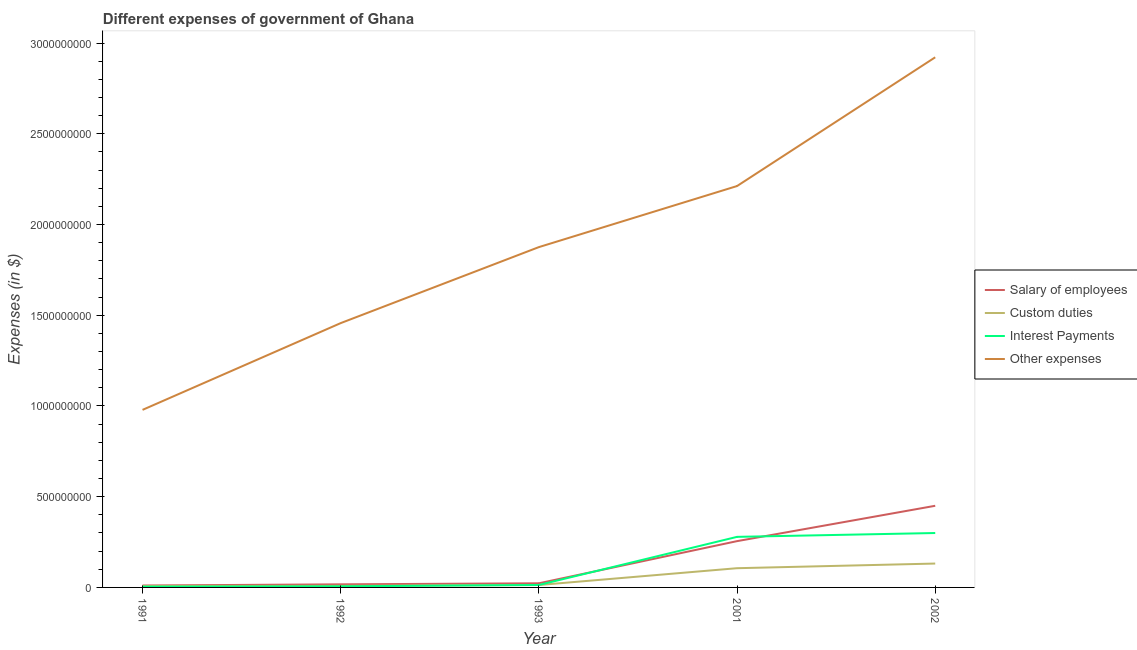How many different coloured lines are there?
Keep it short and to the point. 4. Does the line corresponding to amount spent on salary of employees intersect with the line corresponding to amount spent on other expenses?
Provide a succinct answer. No. Is the number of lines equal to the number of legend labels?
Your answer should be compact. Yes. What is the amount spent on custom duties in 1992?
Your answer should be compact. 8.66e+06. Across all years, what is the maximum amount spent on other expenses?
Ensure brevity in your answer.  2.92e+09. Across all years, what is the minimum amount spent on interest payments?
Offer a very short reply. 4.28e+06. In which year was the amount spent on salary of employees minimum?
Offer a terse response. 1991. What is the total amount spent on salary of employees in the graph?
Offer a terse response. 7.56e+08. What is the difference between the amount spent on salary of employees in 2001 and that in 2002?
Your answer should be compact. -1.95e+08. What is the difference between the amount spent on custom duties in 1991 and the amount spent on salary of employees in 2001?
Provide a succinct answer. -2.47e+08. What is the average amount spent on salary of employees per year?
Offer a terse response. 1.51e+08. In the year 1991, what is the difference between the amount spent on custom duties and amount spent on other expenses?
Your answer should be compact. -9.71e+08. What is the ratio of the amount spent on other expenses in 1991 to that in 1992?
Your answer should be very brief. 0.67. Is the amount spent on salary of employees in 1991 less than that in 2001?
Offer a very short reply. Yes. Is the difference between the amount spent on custom duties in 1991 and 2002 greater than the difference between the amount spent on salary of employees in 1991 and 2002?
Keep it short and to the point. Yes. What is the difference between the highest and the second highest amount spent on other expenses?
Provide a short and direct response. 7.10e+08. What is the difference between the highest and the lowest amount spent on salary of employees?
Make the answer very short. 4.39e+08. In how many years, is the amount spent on custom duties greater than the average amount spent on custom duties taken over all years?
Provide a short and direct response. 2. Is the sum of the amount spent on other expenses in 1993 and 2002 greater than the maximum amount spent on salary of employees across all years?
Your answer should be very brief. Yes. Is it the case that in every year, the sum of the amount spent on custom duties and amount spent on salary of employees is greater than the sum of amount spent on other expenses and amount spent on interest payments?
Offer a very short reply. No. Does the amount spent on salary of employees monotonically increase over the years?
Make the answer very short. Yes. Is the amount spent on other expenses strictly greater than the amount spent on salary of employees over the years?
Give a very brief answer. Yes. How many lines are there?
Offer a very short reply. 4. How many years are there in the graph?
Make the answer very short. 5. Does the graph contain any zero values?
Ensure brevity in your answer.  No. How many legend labels are there?
Your answer should be compact. 4. What is the title of the graph?
Your response must be concise. Different expenses of government of Ghana. Does "Forest" appear as one of the legend labels in the graph?
Your response must be concise. No. What is the label or title of the X-axis?
Provide a short and direct response. Year. What is the label or title of the Y-axis?
Your answer should be compact. Expenses (in $). What is the Expenses (in $) in Salary of employees in 1991?
Give a very brief answer. 1.06e+07. What is the Expenses (in $) in Custom duties in 1991?
Give a very brief answer. 7.93e+06. What is the Expenses (in $) of Interest Payments in 1991?
Your answer should be compact. 4.28e+06. What is the Expenses (in $) of Other expenses in 1991?
Offer a very short reply. 9.79e+08. What is the Expenses (in $) of Salary of employees in 1992?
Give a very brief answer. 1.71e+07. What is the Expenses (in $) in Custom duties in 1992?
Ensure brevity in your answer.  8.66e+06. What is the Expenses (in $) of Interest Payments in 1992?
Ensure brevity in your answer.  6.10e+06. What is the Expenses (in $) in Other expenses in 1992?
Offer a terse response. 1.46e+09. What is the Expenses (in $) of Salary of employees in 1993?
Ensure brevity in your answer.  2.28e+07. What is the Expenses (in $) in Custom duties in 1993?
Give a very brief answer. 1.33e+07. What is the Expenses (in $) of Interest Payments in 1993?
Your response must be concise. 1.35e+07. What is the Expenses (in $) of Other expenses in 1993?
Provide a short and direct response. 1.88e+09. What is the Expenses (in $) in Salary of employees in 2001?
Make the answer very short. 2.55e+08. What is the Expenses (in $) of Custom duties in 2001?
Offer a very short reply. 1.06e+08. What is the Expenses (in $) in Interest Payments in 2001?
Offer a terse response. 2.79e+08. What is the Expenses (in $) in Other expenses in 2001?
Provide a short and direct response. 2.21e+09. What is the Expenses (in $) in Salary of employees in 2002?
Provide a succinct answer. 4.50e+08. What is the Expenses (in $) in Custom duties in 2002?
Your answer should be very brief. 1.32e+08. What is the Expenses (in $) in Interest Payments in 2002?
Your answer should be very brief. 3.00e+08. What is the Expenses (in $) in Other expenses in 2002?
Keep it short and to the point. 2.92e+09. Across all years, what is the maximum Expenses (in $) in Salary of employees?
Give a very brief answer. 4.50e+08. Across all years, what is the maximum Expenses (in $) in Custom duties?
Your answer should be very brief. 1.32e+08. Across all years, what is the maximum Expenses (in $) in Interest Payments?
Your response must be concise. 3.00e+08. Across all years, what is the maximum Expenses (in $) in Other expenses?
Offer a very short reply. 2.92e+09. Across all years, what is the minimum Expenses (in $) in Salary of employees?
Make the answer very short. 1.06e+07. Across all years, what is the minimum Expenses (in $) of Custom duties?
Keep it short and to the point. 7.93e+06. Across all years, what is the minimum Expenses (in $) in Interest Payments?
Keep it short and to the point. 4.28e+06. Across all years, what is the minimum Expenses (in $) in Other expenses?
Your answer should be very brief. 9.79e+08. What is the total Expenses (in $) of Salary of employees in the graph?
Keep it short and to the point. 7.56e+08. What is the total Expenses (in $) of Custom duties in the graph?
Offer a very short reply. 2.67e+08. What is the total Expenses (in $) in Interest Payments in the graph?
Your response must be concise. 6.02e+08. What is the total Expenses (in $) of Other expenses in the graph?
Make the answer very short. 9.45e+09. What is the difference between the Expenses (in $) of Salary of employees in 1991 and that in 1992?
Offer a terse response. -6.55e+06. What is the difference between the Expenses (in $) in Custom duties in 1991 and that in 1992?
Your answer should be very brief. -7.33e+05. What is the difference between the Expenses (in $) of Interest Payments in 1991 and that in 1992?
Provide a short and direct response. -1.82e+06. What is the difference between the Expenses (in $) of Other expenses in 1991 and that in 1992?
Provide a succinct answer. -4.78e+08. What is the difference between the Expenses (in $) of Salary of employees in 1991 and that in 1993?
Offer a terse response. -1.22e+07. What is the difference between the Expenses (in $) in Custom duties in 1991 and that in 1993?
Ensure brevity in your answer.  -5.34e+06. What is the difference between the Expenses (in $) of Interest Payments in 1991 and that in 1993?
Your response must be concise. -9.20e+06. What is the difference between the Expenses (in $) of Other expenses in 1991 and that in 1993?
Your response must be concise. -8.97e+08. What is the difference between the Expenses (in $) of Salary of employees in 1991 and that in 2001?
Provide a short and direct response. -2.45e+08. What is the difference between the Expenses (in $) of Custom duties in 1991 and that in 2001?
Keep it short and to the point. -9.81e+07. What is the difference between the Expenses (in $) in Interest Payments in 1991 and that in 2001?
Make the answer very short. -2.74e+08. What is the difference between the Expenses (in $) of Other expenses in 1991 and that in 2001?
Make the answer very short. -1.23e+09. What is the difference between the Expenses (in $) of Salary of employees in 1991 and that in 2002?
Ensure brevity in your answer.  -4.39e+08. What is the difference between the Expenses (in $) of Custom duties in 1991 and that in 2002?
Keep it short and to the point. -1.24e+08. What is the difference between the Expenses (in $) of Interest Payments in 1991 and that in 2002?
Ensure brevity in your answer.  -2.96e+08. What is the difference between the Expenses (in $) of Other expenses in 1991 and that in 2002?
Give a very brief answer. -1.94e+09. What is the difference between the Expenses (in $) of Salary of employees in 1992 and that in 1993?
Offer a very short reply. -5.65e+06. What is the difference between the Expenses (in $) in Custom duties in 1992 and that in 1993?
Keep it short and to the point. -4.61e+06. What is the difference between the Expenses (in $) in Interest Payments in 1992 and that in 1993?
Your answer should be compact. -7.38e+06. What is the difference between the Expenses (in $) in Other expenses in 1992 and that in 1993?
Keep it short and to the point. -4.19e+08. What is the difference between the Expenses (in $) of Salary of employees in 1992 and that in 2001?
Keep it short and to the point. -2.38e+08. What is the difference between the Expenses (in $) in Custom duties in 1992 and that in 2001?
Give a very brief answer. -9.73e+07. What is the difference between the Expenses (in $) of Interest Payments in 1992 and that in 2001?
Provide a short and direct response. -2.73e+08. What is the difference between the Expenses (in $) in Other expenses in 1992 and that in 2001?
Your answer should be very brief. -7.55e+08. What is the difference between the Expenses (in $) of Salary of employees in 1992 and that in 2002?
Offer a very short reply. -4.33e+08. What is the difference between the Expenses (in $) in Custom duties in 1992 and that in 2002?
Offer a very short reply. -1.23e+08. What is the difference between the Expenses (in $) of Interest Payments in 1992 and that in 2002?
Provide a succinct answer. -2.94e+08. What is the difference between the Expenses (in $) of Other expenses in 1992 and that in 2002?
Offer a very short reply. -1.47e+09. What is the difference between the Expenses (in $) in Salary of employees in 1993 and that in 2001?
Ensure brevity in your answer.  -2.32e+08. What is the difference between the Expenses (in $) in Custom duties in 1993 and that in 2001?
Ensure brevity in your answer.  -9.27e+07. What is the difference between the Expenses (in $) in Interest Payments in 1993 and that in 2001?
Ensure brevity in your answer.  -2.65e+08. What is the difference between the Expenses (in $) of Other expenses in 1993 and that in 2001?
Keep it short and to the point. -3.37e+08. What is the difference between the Expenses (in $) in Salary of employees in 1993 and that in 2002?
Keep it short and to the point. -4.27e+08. What is the difference between the Expenses (in $) of Custom duties in 1993 and that in 2002?
Make the answer very short. -1.18e+08. What is the difference between the Expenses (in $) of Interest Payments in 1993 and that in 2002?
Your answer should be very brief. -2.86e+08. What is the difference between the Expenses (in $) in Other expenses in 1993 and that in 2002?
Provide a succinct answer. -1.05e+09. What is the difference between the Expenses (in $) in Salary of employees in 2001 and that in 2002?
Your answer should be compact. -1.95e+08. What is the difference between the Expenses (in $) in Custom duties in 2001 and that in 2002?
Provide a short and direct response. -2.56e+07. What is the difference between the Expenses (in $) in Interest Payments in 2001 and that in 2002?
Provide a succinct answer. -2.12e+07. What is the difference between the Expenses (in $) of Other expenses in 2001 and that in 2002?
Provide a short and direct response. -7.10e+08. What is the difference between the Expenses (in $) of Salary of employees in 1991 and the Expenses (in $) of Custom duties in 1992?
Provide a short and direct response. 1.90e+06. What is the difference between the Expenses (in $) of Salary of employees in 1991 and the Expenses (in $) of Interest Payments in 1992?
Your answer should be compact. 4.46e+06. What is the difference between the Expenses (in $) of Salary of employees in 1991 and the Expenses (in $) of Other expenses in 1992?
Provide a succinct answer. -1.45e+09. What is the difference between the Expenses (in $) of Custom duties in 1991 and the Expenses (in $) of Interest Payments in 1992?
Provide a short and direct response. 1.82e+06. What is the difference between the Expenses (in $) in Custom duties in 1991 and the Expenses (in $) in Other expenses in 1992?
Offer a very short reply. -1.45e+09. What is the difference between the Expenses (in $) of Interest Payments in 1991 and the Expenses (in $) of Other expenses in 1992?
Offer a very short reply. -1.45e+09. What is the difference between the Expenses (in $) in Salary of employees in 1991 and the Expenses (in $) in Custom duties in 1993?
Your answer should be very brief. -2.71e+06. What is the difference between the Expenses (in $) in Salary of employees in 1991 and the Expenses (in $) in Interest Payments in 1993?
Provide a succinct answer. -2.92e+06. What is the difference between the Expenses (in $) of Salary of employees in 1991 and the Expenses (in $) of Other expenses in 1993?
Offer a terse response. -1.87e+09. What is the difference between the Expenses (in $) in Custom duties in 1991 and the Expenses (in $) in Interest Payments in 1993?
Ensure brevity in your answer.  -5.55e+06. What is the difference between the Expenses (in $) of Custom duties in 1991 and the Expenses (in $) of Other expenses in 1993?
Offer a very short reply. -1.87e+09. What is the difference between the Expenses (in $) of Interest Payments in 1991 and the Expenses (in $) of Other expenses in 1993?
Your answer should be compact. -1.87e+09. What is the difference between the Expenses (in $) of Salary of employees in 1991 and the Expenses (in $) of Custom duties in 2001?
Make the answer very short. -9.54e+07. What is the difference between the Expenses (in $) of Salary of employees in 1991 and the Expenses (in $) of Interest Payments in 2001?
Ensure brevity in your answer.  -2.68e+08. What is the difference between the Expenses (in $) in Salary of employees in 1991 and the Expenses (in $) in Other expenses in 2001?
Keep it short and to the point. -2.20e+09. What is the difference between the Expenses (in $) of Custom duties in 1991 and the Expenses (in $) of Interest Payments in 2001?
Offer a very short reply. -2.71e+08. What is the difference between the Expenses (in $) in Custom duties in 1991 and the Expenses (in $) in Other expenses in 2001?
Keep it short and to the point. -2.20e+09. What is the difference between the Expenses (in $) of Interest Payments in 1991 and the Expenses (in $) of Other expenses in 2001?
Make the answer very short. -2.21e+09. What is the difference between the Expenses (in $) of Salary of employees in 1991 and the Expenses (in $) of Custom duties in 2002?
Offer a terse response. -1.21e+08. What is the difference between the Expenses (in $) in Salary of employees in 1991 and the Expenses (in $) in Interest Payments in 2002?
Offer a very short reply. -2.89e+08. What is the difference between the Expenses (in $) of Salary of employees in 1991 and the Expenses (in $) of Other expenses in 2002?
Your answer should be very brief. -2.91e+09. What is the difference between the Expenses (in $) in Custom duties in 1991 and the Expenses (in $) in Interest Payments in 2002?
Provide a succinct answer. -2.92e+08. What is the difference between the Expenses (in $) of Custom duties in 1991 and the Expenses (in $) of Other expenses in 2002?
Your answer should be compact. -2.91e+09. What is the difference between the Expenses (in $) in Interest Payments in 1991 and the Expenses (in $) in Other expenses in 2002?
Your response must be concise. -2.92e+09. What is the difference between the Expenses (in $) of Salary of employees in 1992 and the Expenses (in $) of Custom duties in 1993?
Offer a terse response. 3.84e+06. What is the difference between the Expenses (in $) in Salary of employees in 1992 and the Expenses (in $) in Interest Payments in 1993?
Keep it short and to the point. 3.63e+06. What is the difference between the Expenses (in $) in Salary of employees in 1992 and the Expenses (in $) in Other expenses in 1993?
Your answer should be very brief. -1.86e+09. What is the difference between the Expenses (in $) in Custom duties in 1992 and the Expenses (in $) in Interest Payments in 1993?
Give a very brief answer. -4.82e+06. What is the difference between the Expenses (in $) of Custom duties in 1992 and the Expenses (in $) of Other expenses in 1993?
Your answer should be very brief. -1.87e+09. What is the difference between the Expenses (in $) in Interest Payments in 1992 and the Expenses (in $) in Other expenses in 1993?
Offer a terse response. -1.87e+09. What is the difference between the Expenses (in $) in Salary of employees in 1992 and the Expenses (in $) in Custom duties in 2001?
Your response must be concise. -8.89e+07. What is the difference between the Expenses (in $) in Salary of employees in 1992 and the Expenses (in $) in Interest Payments in 2001?
Your answer should be very brief. -2.62e+08. What is the difference between the Expenses (in $) in Salary of employees in 1992 and the Expenses (in $) in Other expenses in 2001?
Your response must be concise. -2.20e+09. What is the difference between the Expenses (in $) in Custom duties in 1992 and the Expenses (in $) in Interest Payments in 2001?
Ensure brevity in your answer.  -2.70e+08. What is the difference between the Expenses (in $) in Custom duties in 1992 and the Expenses (in $) in Other expenses in 2001?
Your answer should be very brief. -2.20e+09. What is the difference between the Expenses (in $) of Interest Payments in 1992 and the Expenses (in $) of Other expenses in 2001?
Your answer should be compact. -2.21e+09. What is the difference between the Expenses (in $) of Salary of employees in 1992 and the Expenses (in $) of Custom duties in 2002?
Your response must be concise. -1.14e+08. What is the difference between the Expenses (in $) of Salary of employees in 1992 and the Expenses (in $) of Interest Payments in 2002?
Provide a succinct answer. -2.83e+08. What is the difference between the Expenses (in $) in Salary of employees in 1992 and the Expenses (in $) in Other expenses in 2002?
Offer a very short reply. -2.90e+09. What is the difference between the Expenses (in $) of Custom duties in 1992 and the Expenses (in $) of Interest Payments in 2002?
Make the answer very short. -2.91e+08. What is the difference between the Expenses (in $) of Custom duties in 1992 and the Expenses (in $) of Other expenses in 2002?
Provide a succinct answer. -2.91e+09. What is the difference between the Expenses (in $) of Interest Payments in 1992 and the Expenses (in $) of Other expenses in 2002?
Offer a terse response. -2.92e+09. What is the difference between the Expenses (in $) in Salary of employees in 1993 and the Expenses (in $) in Custom duties in 2001?
Your answer should be compact. -8.32e+07. What is the difference between the Expenses (in $) in Salary of employees in 1993 and the Expenses (in $) in Interest Payments in 2001?
Keep it short and to the point. -2.56e+08. What is the difference between the Expenses (in $) of Salary of employees in 1993 and the Expenses (in $) of Other expenses in 2001?
Ensure brevity in your answer.  -2.19e+09. What is the difference between the Expenses (in $) of Custom duties in 1993 and the Expenses (in $) of Interest Payments in 2001?
Your response must be concise. -2.65e+08. What is the difference between the Expenses (in $) of Custom duties in 1993 and the Expenses (in $) of Other expenses in 2001?
Offer a terse response. -2.20e+09. What is the difference between the Expenses (in $) in Interest Payments in 1993 and the Expenses (in $) in Other expenses in 2001?
Your answer should be compact. -2.20e+09. What is the difference between the Expenses (in $) in Salary of employees in 1993 and the Expenses (in $) in Custom duties in 2002?
Keep it short and to the point. -1.09e+08. What is the difference between the Expenses (in $) of Salary of employees in 1993 and the Expenses (in $) of Interest Payments in 2002?
Your answer should be very brief. -2.77e+08. What is the difference between the Expenses (in $) in Salary of employees in 1993 and the Expenses (in $) in Other expenses in 2002?
Offer a terse response. -2.90e+09. What is the difference between the Expenses (in $) of Custom duties in 1993 and the Expenses (in $) of Interest Payments in 2002?
Make the answer very short. -2.87e+08. What is the difference between the Expenses (in $) of Custom duties in 1993 and the Expenses (in $) of Other expenses in 2002?
Keep it short and to the point. -2.91e+09. What is the difference between the Expenses (in $) in Interest Payments in 1993 and the Expenses (in $) in Other expenses in 2002?
Your answer should be compact. -2.91e+09. What is the difference between the Expenses (in $) of Salary of employees in 2001 and the Expenses (in $) of Custom duties in 2002?
Provide a short and direct response. 1.24e+08. What is the difference between the Expenses (in $) in Salary of employees in 2001 and the Expenses (in $) in Interest Payments in 2002?
Ensure brevity in your answer.  -4.48e+07. What is the difference between the Expenses (in $) in Salary of employees in 2001 and the Expenses (in $) in Other expenses in 2002?
Offer a terse response. -2.67e+09. What is the difference between the Expenses (in $) of Custom duties in 2001 and the Expenses (in $) of Interest Payments in 2002?
Your answer should be very brief. -1.94e+08. What is the difference between the Expenses (in $) of Custom duties in 2001 and the Expenses (in $) of Other expenses in 2002?
Provide a succinct answer. -2.82e+09. What is the difference between the Expenses (in $) in Interest Payments in 2001 and the Expenses (in $) in Other expenses in 2002?
Make the answer very short. -2.64e+09. What is the average Expenses (in $) of Salary of employees per year?
Offer a very short reply. 1.51e+08. What is the average Expenses (in $) of Custom duties per year?
Offer a terse response. 5.35e+07. What is the average Expenses (in $) of Interest Payments per year?
Provide a short and direct response. 1.20e+08. What is the average Expenses (in $) of Other expenses per year?
Provide a short and direct response. 1.89e+09. In the year 1991, what is the difference between the Expenses (in $) of Salary of employees and Expenses (in $) of Custom duties?
Ensure brevity in your answer.  2.63e+06. In the year 1991, what is the difference between the Expenses (in $) in Salary of employees and Expenses (in $) in Interest Payments?
Your response must be concise. 6.27e+06. In the year 1991, what is the difference between the Expenses (in $) of Salary of employees and Expenses (in $) of Other expenses?
Your answer should be very brief. -9.68e+08. In the year 1991, what is the difference between the Expenses (in $) of Custom duties and Expenses (in $) of Interest Payments?
Make the answer very short. 3.64e+06. In the year 1991, what is the difference between the Expenses (in $) of Custom duties and Expenses (in $) of Other expenses?
Your answer should be very brief. -9.71e+08. In the year 1991, what is the difference between the Expenses (in $) of Interest Payments and Expenses (in $) of Other expenses?
Provide a succinct answer. -9.74e+08. In the year 1992, what is the difference between the Expenses (in $) in Salary of employees and Expenses (in $) in Custom duties?
Provide a succinct answer. 8.45e+06. In the year 1992, what is the difference between the Expenses (in $) of Salary of employees and Expenses (in $) of Interest Payments?
Offer a terse response. 1.10e+07. In the year 1992, what is the difference between the Expenses (in $) of Salary of employees and Expenses (in $) of Other expenses?
Ensure brevity in your answer.  -1.44e+09. In the year 1992, what is the difference between the Expenses (in $) in Custom duties and Expenses (in $) in Interest Payments?
Provide a succinct answer. 2.56e+06. In the year 1992, what is the difference between the Expenses (in $) of Custom duties and Expenses (in $) of Other expenses?
Your answer should be compact. -1.45e+09. In the year 1992, what is the difference between the Expenses (in $) in Interest Payments and Expenses (in $) in Other expenses?
Provide a short and direct response. -1.45e+09. In the year 1993, what is the difference between the Expenses (in $) in Salary of employees and Expenses (in $) in Custom duties?
Your answer should be very brief. 9.49e+06. In the year 1993, what is the difference between the Expenses (in $) in Salary of employees and Expenses (in $) in Interest Payments?
Ensure brevity in your answer.  9.28e+06. In the year 1993, what is the difference between the Expenses (in $) of Salary of employees and Expenses (in $) of Other expenses?
Keep it short and to the point. -1.85e+09. In the year 1993, what is the difference between the Expenses (in $) in Custom duties and Expenses (in $) in Interest Payments?
Give a very brief answer. -2.12e+05. In the year 1993, what is the difference between the Expenses (in $) of Custom duties and Expenses (in $) of Other expenses?
Give a very brief answer. -1.86e+09. In the year 1993, what is the difference between the Expenses (in $) of Interest Payments and Expenses (in $) of Other expenses?
Provide a succinct answer. -1.86e+09. In the year 2001, what is the difference between the Expenses (in $) in Salary of employees and Expenses (in $) in Custom duties?
Offer a terse response. 1.49e+08. In the year 2001, what is the difference between the Expenses (in $) of Salary of employees and Expenses (in $) of Interest Payments?
Give a very brief answer. -2.36e+07. In the year 2001, what is the difference between the Expenses (in $) in Salary of employees and Expenses (in $) in Other expenses?
Make the answer very short. -1.96e+09. In the year 2001, what is the difference between the Expenses (in $) of Custom duties and Expenses (in $) of Interest Payments?
Provide a short and direct response. -1.73e+08. In the year 2001, what is the difference between the Expenses (in $) in Custom duties and Expenses (in $) in Other expenses?
Give a very brief answer. -2.11e+09. In the year 2001, what is the difference between the Expenses (in $) in Interest Payments and Expenses (in $) in Other expenses?
Provide a succinct answer. -1.93e+09. In the year 2002, what is the difference between the Expenses (in $) of Salary of employees and Expenses (in $) of Custom duties?
Keep it short and to the point. 3.18e+08. In the year 2002, what is the difference between the Expenses (in $) of Salary of employees and Expenses (in $) of Interest Payments?
Give a very brief answer. 1.50e+08. In the year 2002, what is the difference between the Expenses (in $) of Salary of employees and Expenses (in $) of Other expenses?
Keep it short and to the point. -2.47e+09. In the year 2002, what is the difference between the Expenses (in $) in Custom duties and Expenses (in $) in Interest Payments?
Give a very brief answer. -1.68e+08. In the year 2002, what is the difference between the Expenses (in $) of Custom duties and Expenses (in $) of Other expenses?
Provide a short and direct response. -2.79e+09. In the year 2002, what is the difference between the Expenses (in $) of Interest Payments and Expenses (in $) of Other expenses?
Make the answer very short. -2.62e+09. What is the ratio of the Expenses (in $) in Salary of employees in 1991 to that in 1992?
Provide a succinct answer. 0.62. What is the ratio of the Expenses (in $) in Custom duties in 1991 to that in 1992?
Provide a succinct answer. 0.92. What is the ratio of the Expenses (in $) of Interest Payments in 1991 to that in 1992?
Your response must be concise. 0.7. What is the ratio of the Expenses (in $) in Other expenses in 1991 to that in 1992?
Provide a succinct answer. 0.67. What is the ratio of the Expenses (in $) in Salary of employees in 1991 to that in 1993?
Offer a very short reply. 0.46. What is the ratio of the Expenses (in $) in Custom duties in 1991 to that in 1993?
Offer a terse response. 0.6. What is the ratio of the Expenses (in $) of Interest Payments in 1991 to that in 1993?
Ensure brevity in your answer.  0.32. What is the ratio of the Expenses (in $) in Other expenses in 1991 to that in 1993?
Keep it short and to the point. 0.52. What is the ratio of the Expenses (in $) in Salary of employees in 1991 to that in 2001?
Your answer should be very brief. 0.04. What is the ratio of the Expenses (in $) of Custom duties in 1991 to that in 2001?
Provide a short and direct response. 0.07. What is the ratio of the Expenses (in $) of Interest Payments in 1991 to that in 2001?
Give a very brief answer. 0.02. What is the ratio of the Expenses (in $) of Other expenses in 1991 to that in 2001?
Your answer should be compact. 0.44. What is the ratio of the Expenses (in $) in Salary of employees in 1991 to that in 2002?
Make the answer very short. 0.02. What is the ratio of the Expenses (in $) of Custom duties in 1991 to that in 2002?
Ensure brevity in your answer.  0.06. What is the ratio of the Expenses (in $) of Interest Payments in 1991 to that in 2002?
Offer a very short reply. 0.01. What is the ratio of the Expenses (in $) in Other expenses in 1991 to that in 2002?
Give a very brief answer. 0.33. What is the ratio of the Expenses (in $) in Salary of employees in 1992 to that in 1993?
Make the answer very short. 0.75. What is the ratio of the Expenses (in $) of Custom duties in 1992 to that in 1993?
Ensure brevity in your answer.  0.65. What is the ratio of the Expenses (in $) of Interest Payments in 1992 to that in 1993?
Offer a terse response. 0.45. What is the ratio of the Expenses (in $) in Other expenses in 1992 to that in 1993?
Offer a terse response. 0.78. What is the ratio of the Expenses (in $) in Salary of employees in 1992 to that in 2001?
Provide a succinct answer. 0.07. What is the ratio of the Expenses (in $) of Custom duties in 1992 to that in 2001?
Ensure brevity in your answer.  0.08. What is the ratio of the Expenses (in $) of Interest Payments in 1992 to that in 2001?
Your response must be concise. 0.02. What is the ratio of the Expenses (in $) of Other expenses in 1992 to that in 2001?
Make the answer very short. 0.66. What is the ratio of the Expenses (in $) of Salary of employees in 1992 to that in 2002?
Make the answer very short. 0.04. What is the ratio of the Expenses (in $) in Custom duties in 1992 to that in 2002?
Offer a very short reply. 0.07. What is the ratio of the Expenses (in $) of Interest Payments in 1992 to that in 2002?
Offer a terse response. 0.02. What is the ratio of the Expenses (in $) of Other expenses in 1992 to that in 2002?
Your answer should be compact. 0.5. What is the ratio of the Expenses (in $) of Salary of employees in 1993 to that in 2001?
Your response must be concise. 0.09. What is the ratio of the Expenses (in $) of Custom duties in 1993 to that in 2001?
Ensure brevity in your answer.  0.13. What is the ratio of the Expenses (in $) of Interest Payments in 1993 to that in 2001?
Give a very brief answer. 0.05. What is the ratio of the Expenses (in $) in Other expenses in 1993 to that in 2001?
Keep it short and to the point. 0.85. What is the ratio of the Expenses (in $) in Salary of employees in 1993 to that in 2002?
Your answer should be compact. 0.05. What is the ratio of the Expenses (in $) in Custom duties in 1993 to that in 2002?
Your answer should be very brief. 0.1. What is the ratio of the Expenses (in $) in Interest Payments in 1993 to that in 2002?
Provide a succinct answer. 0.04. What is the ratio of the Expenses (in $) in Other expenses in 1993 to that in 2002?
Give a very brief answer. 0.64. What is the ratio of the Expenses (in $) of Salary of employees in 2001 to that in 2002?
Provide a short and direct response. 0.57. What is the ratio of the Expenses (in $) of Custom duties in 2001 to that in 2002?
Keep it short and to the point. 0.81. What is the ratio of the Expenses (in $) in Interest Payments in 2001 to that in 2002?
Offer a very short reply. 0.93. What is the ratio of the Expenses (in $) in Other expenses in 2001 to that in 2002?
Make the answer very short. 0.76. What is the difference between the highest and the second highest Expenses (in $) in Salary of employees?
Provide a succinct answer. 1.95e+08. What is the difference between the highest and the second highest Expenses (in $) of Custom duties?
Your answer should be compact. 2.56e+07. What is the difference between the highest and the second highest Expenses (in $) of Interest Payments?
Keep it short and to the point. 2.12e+07. What is the difference between the highest and the second highest Expenses (in $) of Other expenses?
Your response must be concise. 7.10e+08. What is the difference between the highest and the lowest Expenses (in $) in Salary of employees?
Your answer should be compact. 4.39e+08. What is the difference between the highest and the lowest Expenses (in $) in Custom duties?
Provide a short and direct response. 1.24e+08. What is the difference between the highest and the lowest Expenses (in $) of Interest Payments?
Provide a succinct answer. 2.96e+08. What is the difference between the highest and the lowest Expenses (in $) of Other expenses?
Your response must be concise. 1.94e+09. 